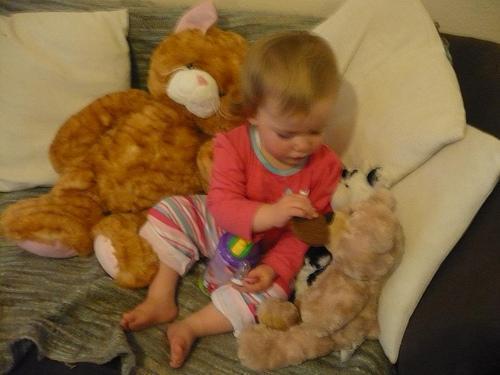Is the given caption "The person is in the couch." fitting for the image?
Answer yes or no. Yes. 